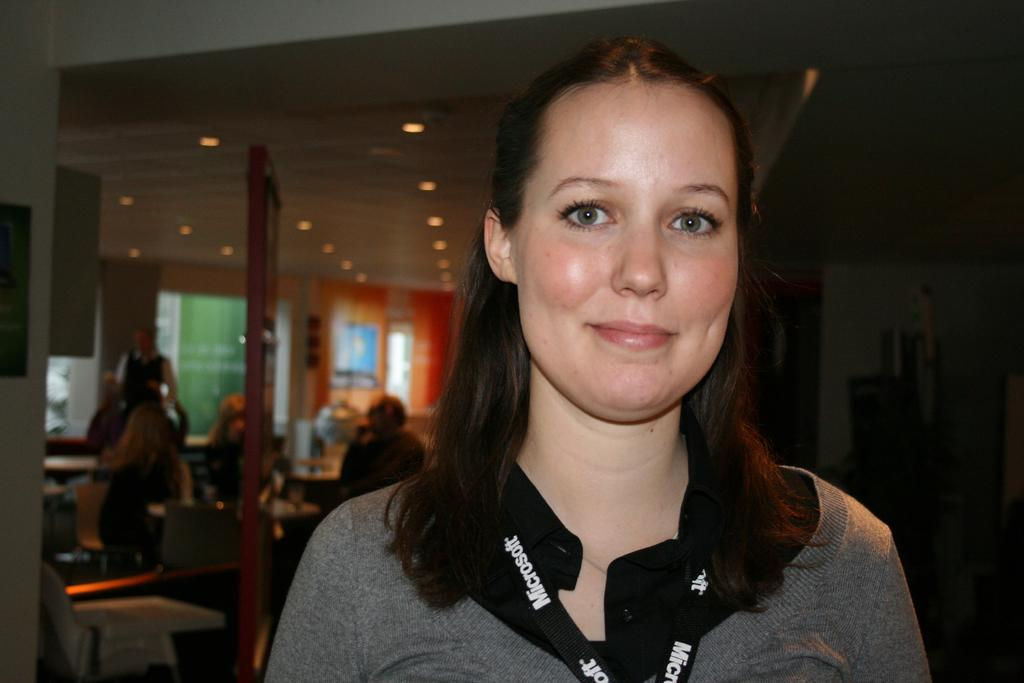<image>
Write a terse but informative summary of the picture. A woman has a black lanyard around her next with Microsoft spelled out in white letters 